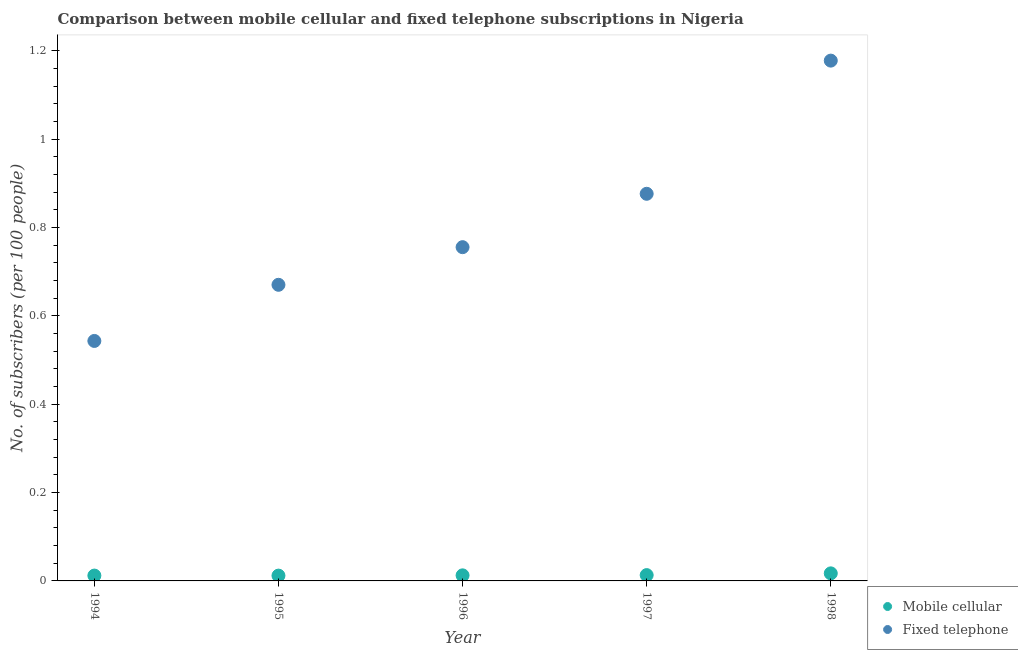What is the number of fixed telephone subscribers in 1995?
Offer a terse response. 0.67. Across all years, what is the maximum number of fixed telephone subscribers?
Give a very brief answer. 1.18. Across all years, what is the minimum number of fixed telephone subscribers?
Your response must be concise. 0.54. In which year was the number of fixed telephone subscribers minimum?
Your answer should be compact. 1994. What is the total number of mobile cellular subscribers in the graph?
Your answer should be compact. 0.07. What is the difference between the number of fixed telephone subscribers in 1996 and that in 1998?
Keep it short and to the point. -0.42. What is the difference between the number of fixed telephone subscribers in 1994 and the number of mobile cellular subscribers in 1996?
Your answer should be very brief. 0.53. What is the average number of fixed telephone subscribers per year?
Your answer should be very brief. 0.8. In the year 1996, what is the difference between the number of fixed telephone subscribers and number of mobile cellular subscribers?
Make the answer very short. 0.74. In how many years, is the number of fixed telephone subscribers greater than 0.88?
Offer a very short reply. 1. What is the ratio of the number of mobile cellular subscribers in 1995 to that in 1997?
Offer a very short reply. 0.91. Is the number of mobile cellular subscribers in 1995 less than that in 1996?
Provide a succinct answer. Yes. Is the difference between the number of fixed telephone subscribers in 1994 and 1997 greater than the difference between the number of mobile cellular subscribers in 1994 and 1997?
Provide a succinct answer. No. What is the difference between the highest and the second highest number of mobile cellular subscribers?
Provide a succinct answer. 0. What is the difference between the highest and the lowest number of mobile cellular subscribers?
Your answer should be compact. 0.01. In how many years, is the number of mobile cellular subscribers greater than the average number of mobile cellular subscribers taken over all years?
Provide a short and direct response. 1. Is the sum of the number of fixed telephone subscribers in 1995 and 1997 greater than the maximum number of mobile cellular subscribers across all years?
Offer a very short reply. Yes. How many dotlines are there?
Make the answer very short. 2. Does the graph contain any zero values?
Ensure brevity in your answer.  No. How many legend labels are there?
Your answer should be compact. 2. What is the title of the graph?
Ensure brevity in your answer.  Comparison between mobile cellular and fixed telephone subscriptions in Nigeria. What is the label or title of the X-axis?
Your answer should be very brief. Year. What is the label or title of the Y-axis?
Offer a very short reply. No. of subscribers (per 100 people). What is the No. of subscribers (per 100 people) of Mobile cellular in 1994?
Offer a very short reply. 0.01. What is the No. of subscribers (per 100 people) in Fixed telephone in 1994?
Provide a short and direct response. 0.54. What is the No. of subscribers (per 100 people) of Mobile cellular in 1995?
Provide a succinct answer. 0.01. What is the No. of subscribers (per 100 people) of Fixed telephone in 1995?
Provide a succinct answer. 0.67. What is the No. of subscribers (per 100 people) in Mobile cellular in 1996?
Your answer should be very brief. 0.01. What is the No. of subscribers (per 100 people) of Fixed telephone in 1996?
Keep it short and to the point. 0.76. What is the No. of subscribers (per 100 people) of Mobile cellular in 1997?
Provide a short and direct response. 0.01. What is the No. of subscribers (per 100 people) of Fixed telephone in 1997?
Make the answer very short. 0.88. What is the No. of subscribers (per 100 people) of Mobile cellular in 1998?
Make the answer very short. 0.02. What is the No. of subscribers (per 100 people) of Fixed telephone in 1998?
Your answer should be compact. 1.18. Across all years, what is the maximum No. of subscribers (per 100 people) in Mobile cellular?
Your response must be concise. 0.02. Across all years, what is the maximum No. of subscribers (per 100 people) of Fixed telephone?
Provide a short and direct response. 1.18. Across all years, what is the minimum No. of subscribers (per 100 people) in Mobile cellular?
Give a very brief answer. 0.01. Across all years, what is the minimum No. of subscribers (per 100 people) in Fixed telephone?
Keep it short and to the point. 0.54. What is the total No. of subscribers (per 100 people) of Mobile cellular in the graph?
Keep it short and to the point. 0.07. What is the total No. of subscribers (per 100 people) in Fixed telephone in the graph?
Your response must be concise. 4.02. What is the difference between the No. of subscribers (per 100 people) of Fixed telephone in 1994 and that in 1995?
Your answer should be very brief. -0.13. What is the difference between the No. of subscribers (per 100 people) of Mobile cellular in 1994 and that in 1996?
Your answer should be compact. -0. What is the difference between the No. of subscribers (per 100 people) of Fixed telephone in 1994 and that in 1996?
Your answer should be very brief. -0.21. What is the difference between the No. of subscribers (per 100 people) of Mobile cellular in 1994 and that in 1997?
Give a very brief answer. -0. What is the difference between the No. of subscribers (per 100 people) of Fixed telephone in 1994 and that in 1997?
Give a very brief answer. -0.33. What is the difference between the No. of subscribers (per 100 people) in Mobile cellular in 1994 and that in 1998?
Offer a terse response. -0.01. What is the difference between the No. of subscribers (per 100 people) in Fixed telephone in 1994 and that in 1998?
Ensure brevity in your answer.  -0.63. What is the difference between the No. of subscribers (per 100 people) of Mobile cellular in 1995 and that in 1996?
Your answer should be very brief. -0. What is the difference between the No. of subscribers (per 100 people) of Fixed telephone in 1995 and that in 1996?
Give a very brief answer. -0.09. What is the difference between the No. of subscribers (per 100 people) of Mobile cellular in 1995 and that in 1997?
Give a very brief answer. -0. What is the difference between the No. of subscribers (per 100 people) of Fixed telephone in 1995 and that in 1997?
Make the answer very short. -0.21. What is the difference between the No. of subscribers (per 100 people) in Mobile cellular in 1995 and that in 1998?
Keep it short and to the point. -0.01. What is the difference between the No. of subscribers (per 100 people) in Fixed telephone in 1995 and that in 1998?
Keep it short and to the point. -0.51. What is the difference between the No. of subscribers (per 100 people) of Mobile cellular in 1996 and that in 1997?
Offer a very short reply. -0. What is the difference between the No. of subscribers (per 100 people) in Fixed telephone in 1996 and that in 1997?
Provide a succinct answer. -0.12. What is the difference between the No. of subscribers (per 100 people) of Mobile cellular in 1996 and that in 1998?
Keep it short and to the point. -0. What is the difference between the No. of subscribers (per 100 people) of Fixed telephone in 1996 and that in 1998?
Provide a succinct answer. -0.42. What is the difference between the No. of subscribers (per 100 people) of Mobile cellular in 1997 and that in 1998?
Ensure brevity in your answer.  -0. What is the difference between the No. of subscribers (per 100 people) in Fixed telephone in 1997 and that in 1998?
Offer a terse response. -0.3. What is the difference between the No. of subscribers (per 100 people) in Mobile cellular in 1994 and the No. of subscribers (per 100 people) in Fixed telephone in 1995?
Make the answer very short. -0.66. What is the difference between the No. of subscribers (per 100 people) in Mobile cellular in 1994 and the No. of subscribers (per 100 people) in Fixed telephone in 1996?
Ensure brevity in your answer.  -0.74. What is the difference between the No. of subscribers (per 100 people) in Mobile cellular in 1994 and the No. of subscribers (per 100 people) in Fixed telephone in 1997?
Keep it short and to the point. -0.86. What is the difference between the No. of subscribers (per 100 people) in Mobile cellular in 1994 and the No. of subscribers (per 100 people) in Fixed telephone in 1998?
Your response must be concise. -1.17. What is the difference between the No. of subscribers (per 100 people) in Mobile cellular in 1995 and the No. of subscribers (per 100 people) in Fixed telephone in 1996?
Keep it short and to the point. -0.74. What is the difference between the No. of subscribers (per 100 people) in Mobile cellular in 1995 and the No. of subscribers (per 100 people) in Fixed telephone in 1997?
Keep it short and to the point. -0.86. What is the difference between the No. of subscribers (per 100 people) in Mobile cellular in 1995 and the No. of subscribers (per 100 people) in Fixed telephone in 1998?
Your response must be concise. -1.17. What is the difference between the No. of subscribers (per 100 people) of Mobile cellular in 1996 and the No. of subscribers (per 100 people) of Fixed telephone in 1997?
Offer a very short reply. -0.86. What is the difference between the No. of subscribers (per 100 people) in Mobile cellular in 1996 and the No. of subscribers (per 100 people) in Fixed telephone in 1998?
Provide a short and direct response. -1.17. What is the difference between the No. of subscribers (per 100 people) in Mobile cellular in 1997 and the No. of subscribers (per 100 people) in Fixed telephone in 1998?
Your answer should be very brief. -1.16. What is the average No. of subscribers (per 100 people) in Mobile cellular per year?
Your answer should be very brief. 0.01. What is the average No. of subscribers (per 100 people) of Fixed telephone per year?
Your answer should be compact. 0.8. In the year 1994, what is the difference between the No. of subscribers (per 100 people) in Mobile cellular and No. of subscribers (per 100 people) in Fixed telephone?
Make the answer very short. -0.53. In the year 1995, what is the difference between the No. of subscribers (per 100 people) in Mobile cellular and No. of subscribers (per 100 people) in Fixed telephone?
Ensure brevity in your answer.  -0.66. In the year 1996, what is the difference between the No. of subscribers (per 100 people) in Mobile cellular and No. of subscribers (per 100 people) in Fixed telephone?
Offer a very short reply. -0.74. In the year 1997, what is the difference between the No. of subscribers (per 100 people) of Mobile cellular and No. of subscribers (per 100 people) of Fixed telephone?
Your response must be concise. -0.86. In the year 1998, what is the difference between the No. of subscribers (per 100 people) of Mobile cellular and No. of subscribers (per 100 people) of Fixed telephone?
Your answer should be compact. -1.16. What is the ratio of the No. of subscribers (per 100 people) in Mobile cellular in 1994 to that in 1995?
Make the answer very short. 1.01. What is the ratio of the No. of subscribers (per 100 people) in Fixed telephone in 1994 to that in 1995?
Provide a short and direct response. 0.81. What is the ratio of the No. of subscribers (per 100 people) in Mobile cellular in 1994 to that in 1996?
Provide a short and direct response. 0.96. What is the ratio of the No. of subscribers (per 100 people) of Fixed telephone in 1994 to that in 1996?
Offer a very short reply. 0.72. What is the ratio of the No. of subscribers (per 100 people) in Mobile cellular in 1994 to that in 1997?
Give a very brief answer. 0.92. What is the ratio of the No. of subscribers (per 100 people) of Fixed telephone in 1994 to that in 1997?
Provide a succinct answer. 0.62. What is the ratio of the No. of subscribers (per 100 people) of Mobile cellular in 1994 to that in 1998?
Ensure brevity in your answer.  0.71. What is the ratio of the No. of subscribers (per 100 people) of Fixed telephone in 1994 to that in 1998?
Make the answer very short. 0.46. What is the ratio of the No. of subscribers (per 100 people) of Fixed telephone in 1995 to that in 1996?
Give a very brief answer. 0.89. What is the ratio of the No. of subscribers (per 100 people) of Mobile cellular in 1995 to that in 1997?
Your answer should be compact. 0.91. What is the ratio of the No. of subscribers (per 100 people) in Fixed telephone in 1995 to that in 1997?
Your response must be concise. 0.76. What is the ratio of the No. of subscribers (per 100 people) in Mobile cellular in 1995 to that in 1998?
Provide a succinct answer. 0.7. What is the ratio of the No. of subscribers (per 100 people) of Fixed telephone in 1995 to that in 1998?
Your answer should be very brief. 0.57. What is the ratio of the No. of subscribers (per 100 people) of Mobile cellular in 1996 to that in 1997?
Make the answer very short. 0.96. What is the ratio of the No. of subscribers (per 100 people) of Fixed telephone in 1996 to that in 1997?
Provide a succinct answer. 0.86. What is the ratio of the No. of subscribers (per 100 people) of Mobile cellular in 1996 to that in 1998?
Ensure brevity in your answer.  0.74. What is the ratio of the No. of subscribers (per 100 people) of Fixed telephone in 1996 to that in 1998?
Make the answer very short. 0.64. What is the ratio of the No. of subscribers (per 100 people) in Mobile cellular in 1997 to that in 1998?
Your answer should be compact. 0.77. What is the ratio of the No. of subscribers (per 100 people) in Fixed telephone in 1997 to that in 1998?
Your answer should be compact. 0.74. What is the difference between the highest and the second highest No. of subscribers (per 100 people) of Mobile cellular?
Your response must be concise. 0. What is the difference between the highest and the second highest No. of subscribers (per 100 people) in Fixed telephone?
Your response must be concise. 0.3. What is the difference between the highest and the lowest No. of subscribers (per 100 people) in Mobile cellular?
Your answer should be very brief. 0.01. What is the difference between the highest and the lowest No. of subscribers (per 100 people) of Fixed telephone?
Ensure brevity in your answer.  0.63. 